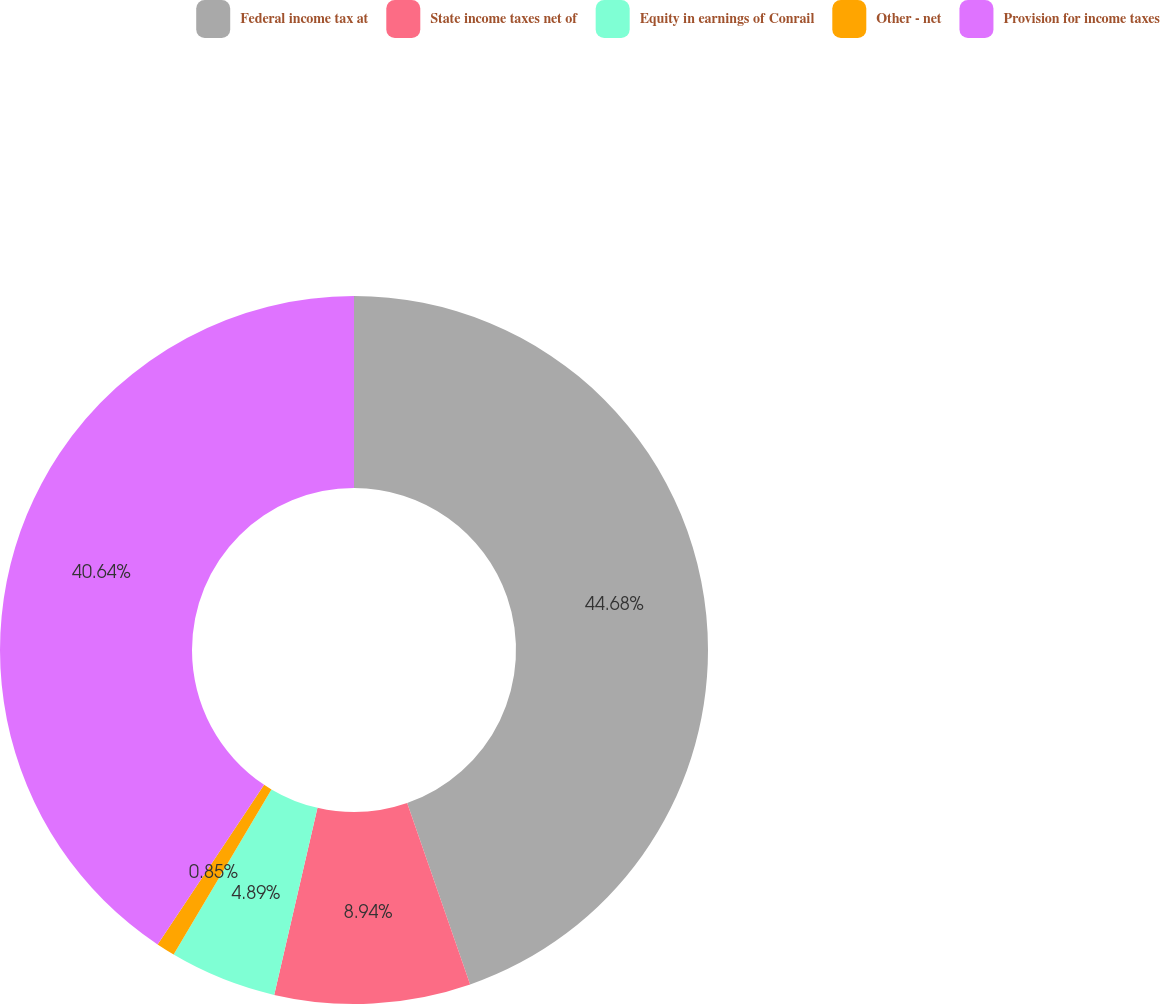<chart> <loc_0><loc_0><loc_500><loc_500><pie_chart><fcel>Federal income tax at<fcel>State income taxes net of<fcel>Equity in earnings of Conrail<fcel>Other - net<fcel>Provision for income taxes<nl><fcel>44.68%<fcel>8.94%<fcel>4.89%<fcel>0.85%<fcel>40.64%<nl></chart> 